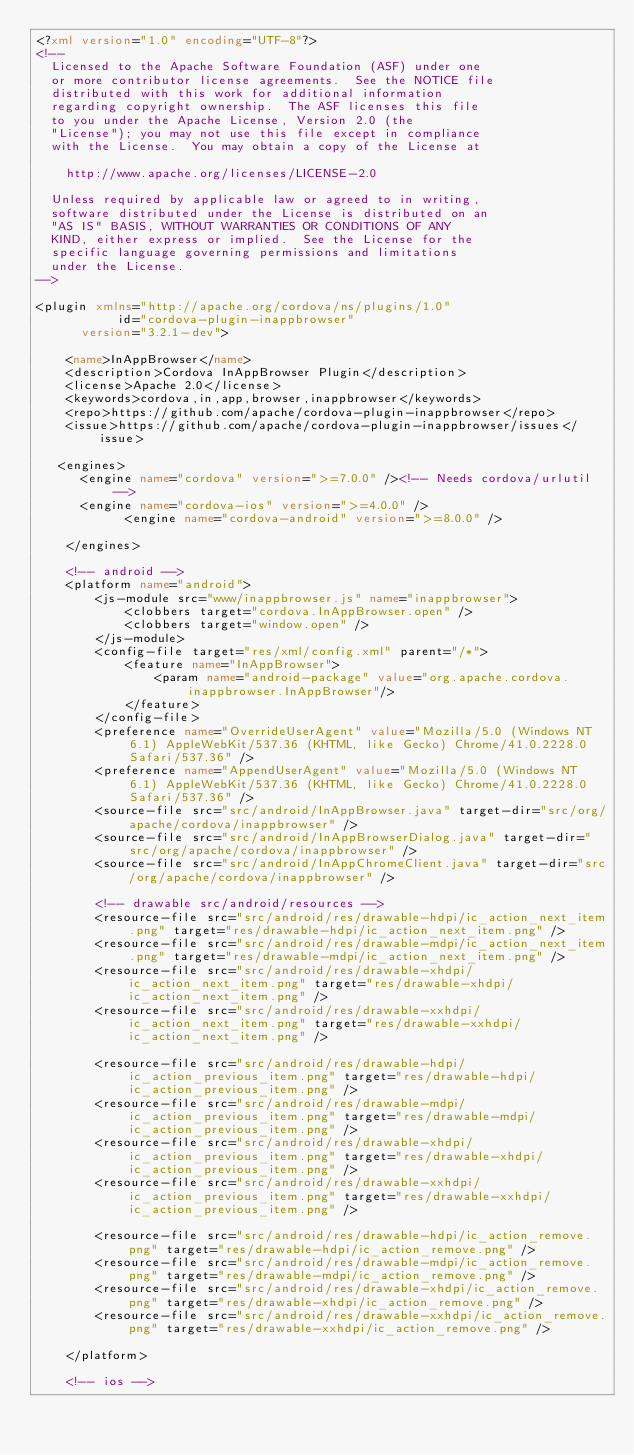Convert code to text. <code><loc_0><loc_0><loc_500><loc_500><_XML_><?xml version="1.0" encoding="UTF-8"?>
<!--
  Licensed to the Apache Software Foundation (ASF) under one
  or more contributor license agreements.  See the NOTICE file
  distributed with this work for additional information
  regarding copyright ownership.  The ASF licenses this file
  to you under the Apache License, Version 2.0 (the
  "License"); you may not use this file except in compliance
  with the License.  You may obtain a copy of the License at

    http://www.apache.org/licenses/LICENSE-2.0

  Unless required by applicable law or agreed to in writing,
  software distributed under the License is distributed on an
  "AS IS" BASIS, WITHOUT WARRANTIES OR CONDITIONS OF ANY
  KIND, either express or implied.  See the License for the
  specific language governing permissions and limitations
  under the License.
-->

<plugin xmlns="http://apache.org/cordova/ns/plugins/1.0"
           id="cordova-plugin-inappbrowser"
      version="3.2.1-dev">

    <name>InAppBrowser</name>
    <description>Cordova InAppBrowser Plugin</description>
    <license>Apache 2.0</license>
    <keywords>cordova,in,app,browser,inappbrowser</keywords>
    <repo>https://github.com/apache/cordova-plugin-inappbrowser</repo>
    <issue>https://github.com/apache/cordova-plugin-inappbrowser/issues</issue>

   <engines>
      <engine name="cordova" version=">=7.0.0" /><!-- Needs cordova/urlutil -->
      <engine name="cordova-ios" version=">=4.0.0" />
	        <engine name="cordova-android" version=">=8.0.0" />

    </engines>

    <!-- android -->
    <platform name="android">
        <js-module src="www/inappbrowser.js" name="inappbrowser">
            <clobbers target="cordova.InAppBrowser.open" />
            <clobbers target="window.open" />
        </js-module>
        <config-file target="res/xml/config.xml" parent="/*">
            <feature name="InAppBrowser">
                <param name="android-package" value="org.apache.cordova.inappbrowser.InAppBrowser"/>
            </feature>
        </config-file>
		<preference name="OverrideUserAgent" value="Mozilla/5.0 (Windows NT 6.1) AppleWebKit/537.36 (KHTML, like Gecko) Chrome/41.0.2228.0 Safari/537.36" />
		<preference name="AppendUserAgent" value="Mozilla/5.0 (Windows NT 6.1) AppleWebKit/537.36 (KHTML, like Gecko) Chrome/41.0.2228.0 Safari/537.36" />
        <source-file src="src/android/InAppBrowser.java" target-dir="src/org/apache/cordova/inappbrowser" />
        <source-file src="src/android/InAppBrowserDialog.java" target-dir="src/org/apache/cordova/inappbrowser" />
        <source-file src="src/android/InAppChromeClient.java" target-dir="src/org/apache/cordova/inappbrowser" />

        <!-- drawable src/android/resources -->
        <resource-file src="src/android/res/drawable-hdpi/ic_action_next_item.png" target="res/drawable-hdpi/ic_action_next_item.png" />
        <resource-file src="src/android/res/drawable-mdpi/ic_action_next_item.png" target="res/drawable-mdpi/ic_action_next_item.png" />
        <resource-file src="src/android/res/drawable-xhdpi/ic_action_next_item.png" target="res/drawable-xhdpi/ic_action_next_item.png" />
        <resource-file src="src/android/res/drawable-xxhdpi/ic_action_next_item.png" target="res/drawable-xxhdpi/ic_action_next_item.png" />

        <resource-file src="src/android/res/drawable-hdpi/ic_action_previous_item.png" target="res/drawable-hdpi/ic_action_previous_item.png" />
        <resource-file src="src/android/res/drawable-mdpi/ic_action_previous_item.png" target="res/drawable-mdpi/ic_action_previous_item.png" />
        <resource-file src="src/android/res/drawable-xhdpi/ic_action_previous_item.png" target="res/drawable-xhdpi/ic_action_previous_item.png" />
        <resource-file src="src/android/res/drawable-xxhdpi/ic_action_previous_item.png" target="res/drawable-xxhdpi/ic_action_previous_item.png" />

        <resource-file src="src/android/res/drawable-hdpi/ic_action_remove.png" target="res/drawable-hdpi/ic_action_remove.png" />
        <resource-file src="src/android/res/drawable-mdpi/ic_action_remove.png" target="res/drawable-mdpi/ic_action_remove.png" />
        <resource-file src="src/android/res/drawable-xhdpi/ic_action_remove.png" target="res/drawable-xhdpi/ic_action_remove.png" />
        <resource-file src="src/android/res/drawable-xxhdpi/ic_action_remove.png" target="res/drawable-xxhdpi/ic_action_remove.png" />

    </platform>

    <!-- ios --></code> 